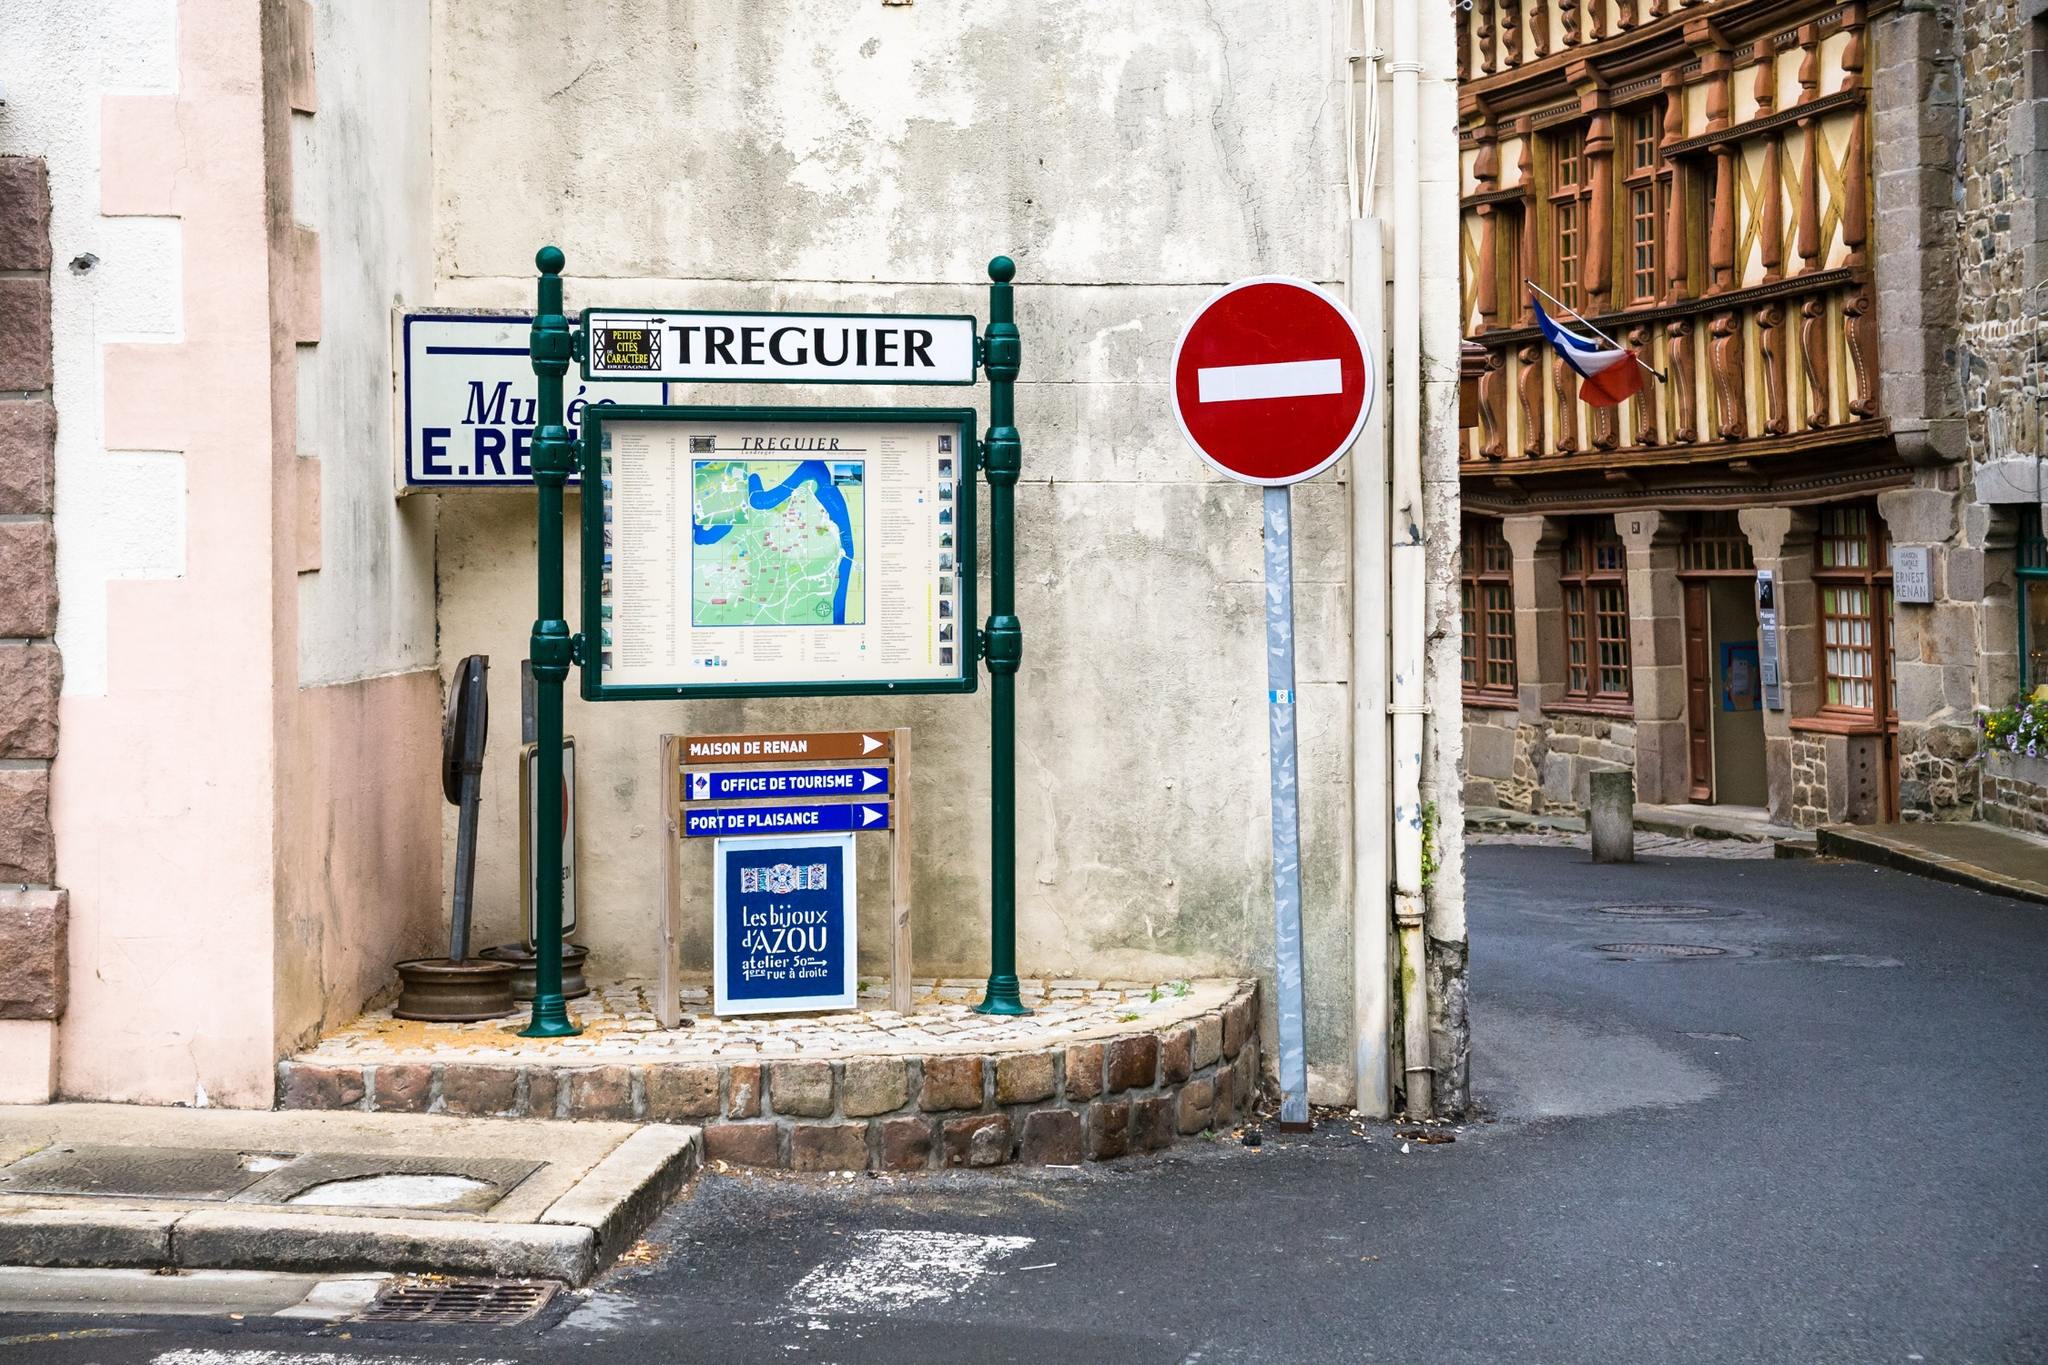Can you elaborate on the elements of the picture provided? The image showcases a historic corner in Tréguier, France. You can see a detailed information board with a map, indicating key tourist spots in the area, placed on a charming cobblestone path. Adjacent to it, a classic European no entry sign balances the composition. On the right, you see an impressive timber-framed building adorned with the French flag, hinting at the area's rich history and possibly housing a local museum as indicated by the 'Musée E.R. Tréguier' sign. The scene captures a blend of traditional architecture and modern street signage, illustrating a typical picturesque French town street. 